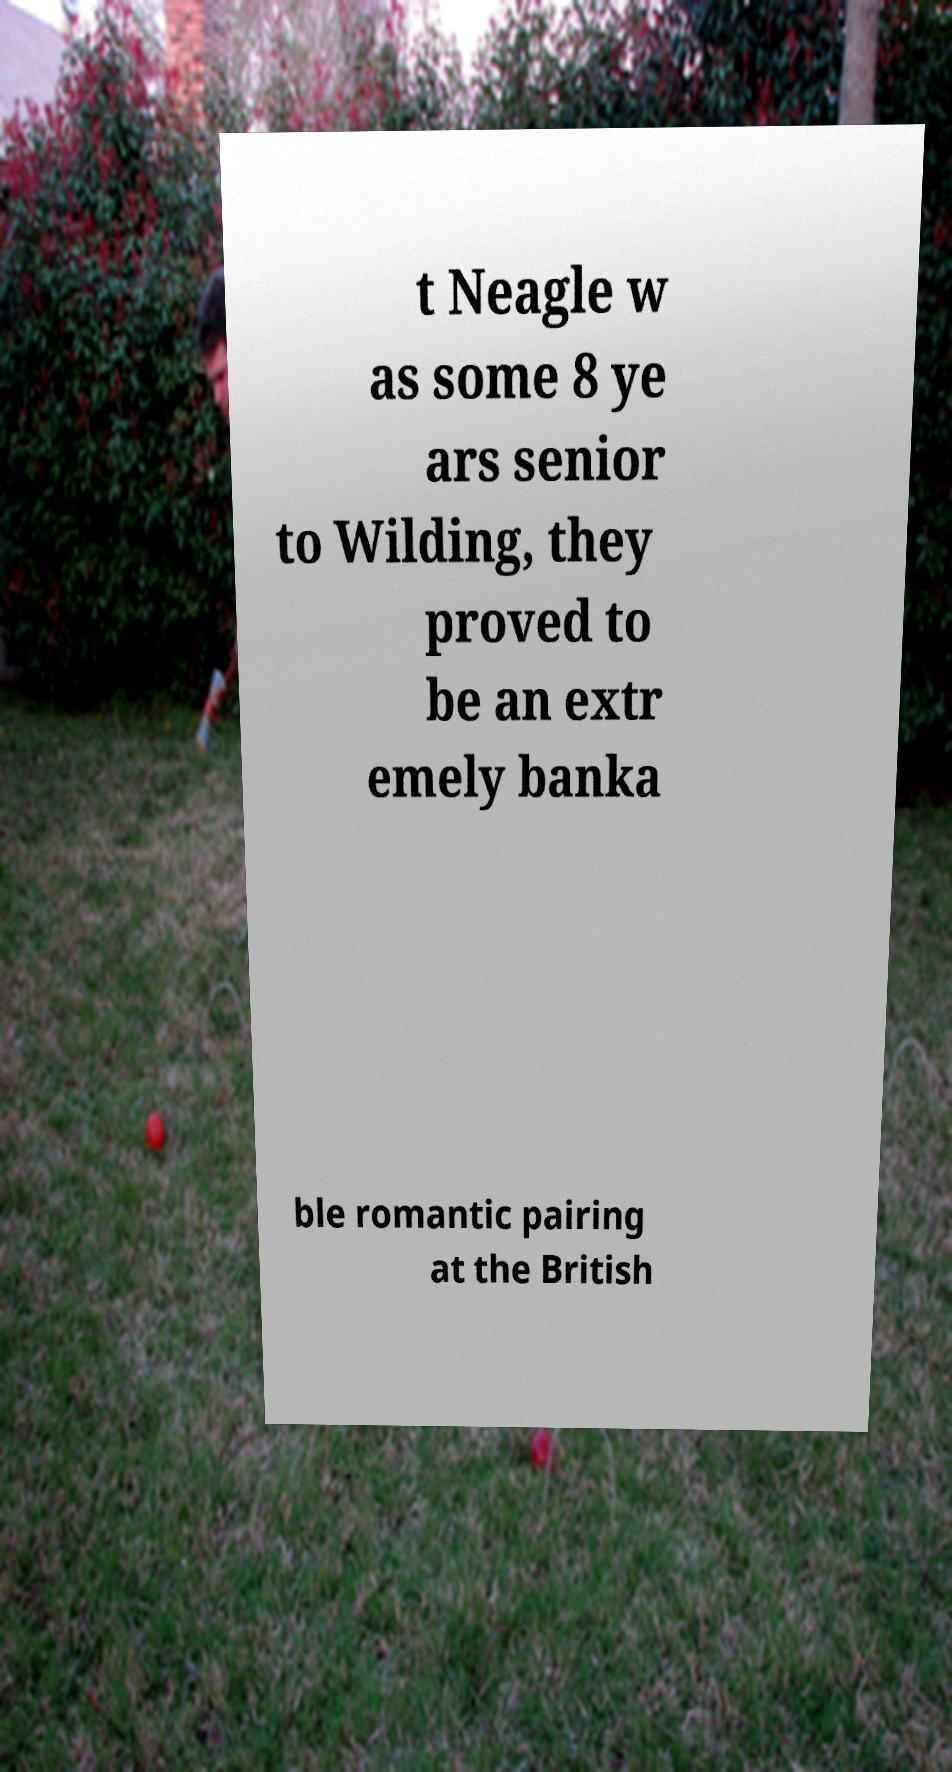There's text embedded in this image that I need extracted. Can you transcribe it verbatim? t Neagle w as some 8 ye ars senior to Wilding, they proved to be an extr emely banka ble romantic pairing at the British 